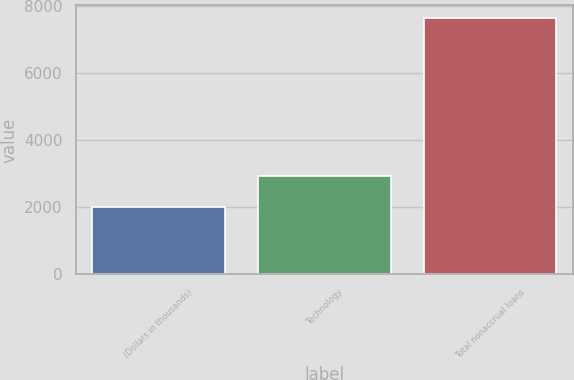<chart> <loc_0><loc_0><loc_500><loc_500><bar_chart><fcel>(Dollars in thousands)<fcel>Technology<fcel>Total nonaccrual loans<nl><fcel>2007<fcel>2936<fcel>7634<nl></chart> 